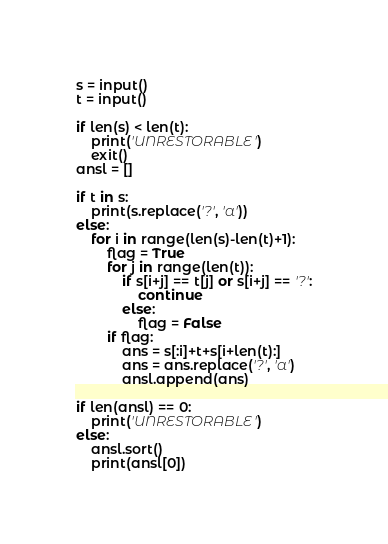<code> <loc_0><loc_0><loc_500><loc_500><_Python_>s = input()
t = input()

if len(s) < len(t):
    print('UNRESTORABLE')
    exit()
ansl = []

if t in s:
    print(s.replace('?', 'a'))
else:
    for i in range(len(s)-len(t)+1):
        flag = True
        for j in range(len(t)):
            if s[i+j] == t[j] or s[i+j] == '?':
                continue
            else:
                flag = False
        if flag:
            ans = s[:i]+t+s[i+len(t):]
            ans = ans.replace('?', 'a')
            ansl.append(ans)

if len(ansl) == 0:
    print('UNRESTORABLE')
else:
    ansl.sort()
    print(ansl[0])
</code> 